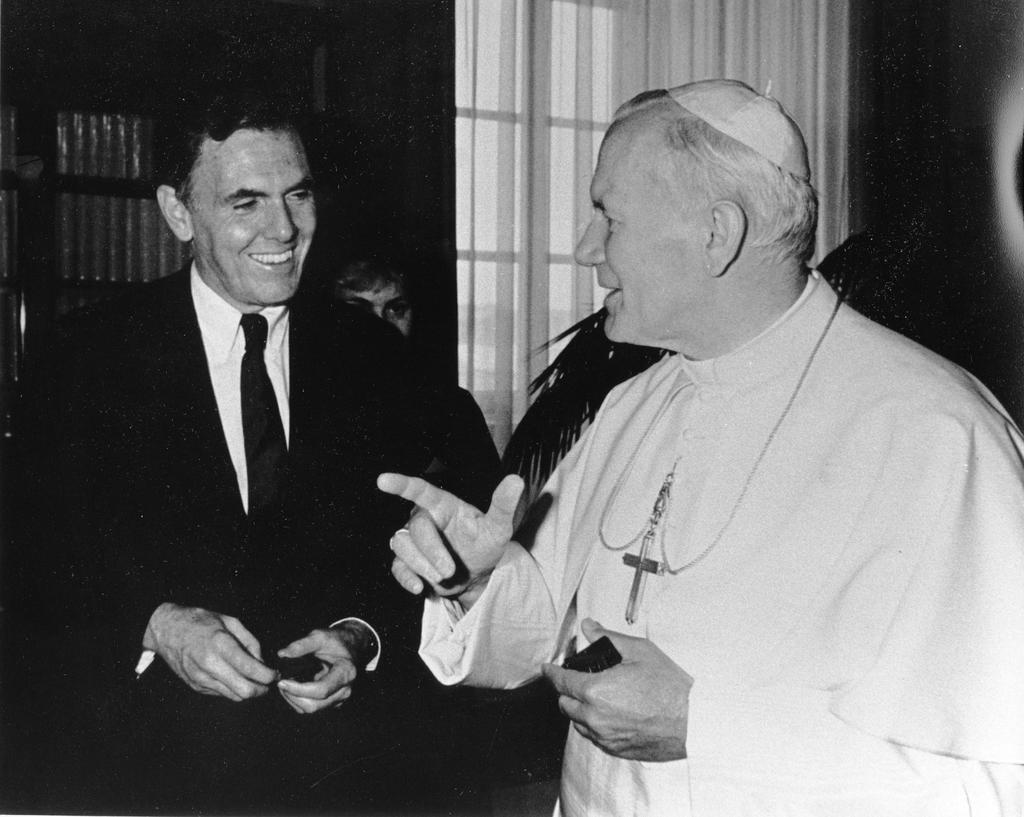How would you summarize this image in a sentence or two? In this image I can see people where one man is in suit and tie and I can also see smile on his face. 